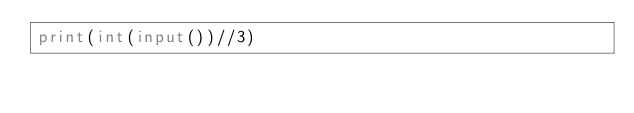<code> <loc_0><loc_0><loc_500><loc_500><_Python_>print(int(input())//3)</code> 